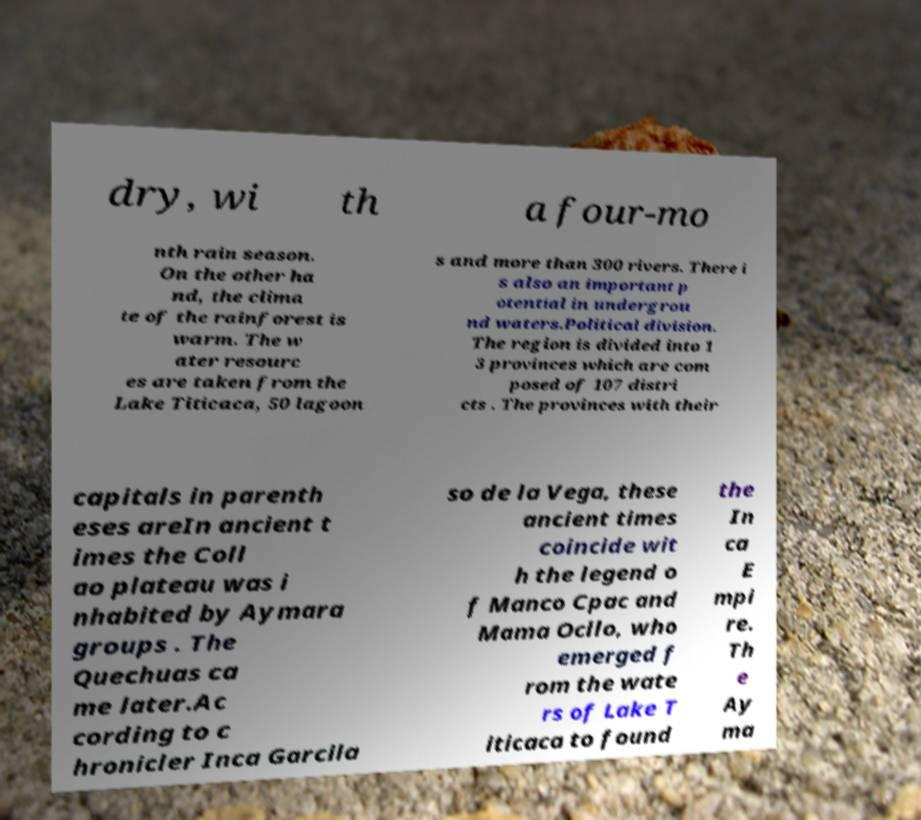Please identify and transcribe the text found in this image. dry, wi th a four-mo nth rain season. On the other ha nd, the clima te of the rainforest is warm. The w ater resourc es are taken from the Lake Titicaca, 50 lagoon s and more than 300 rivers. There i s also an important p otential in undergrou nd waters.Political division. The region is divided into 1 3 provinces which are com posed of 107 distri cts . The provinces with their capitals in parenth eses areIn ancient t imes the Coll ao plateau was i nhabited by Aymara groups . The Quechuas ca me later.Ac cording to c hronicler Inca Garcila so de la Vega, these ancient times coincide wit h the legend o f Manco Cpac and Mama Ocllo, who emerged f rom the wate rs of Lake T iticaca to found the In ca E mpi re. Th e Ay ma 